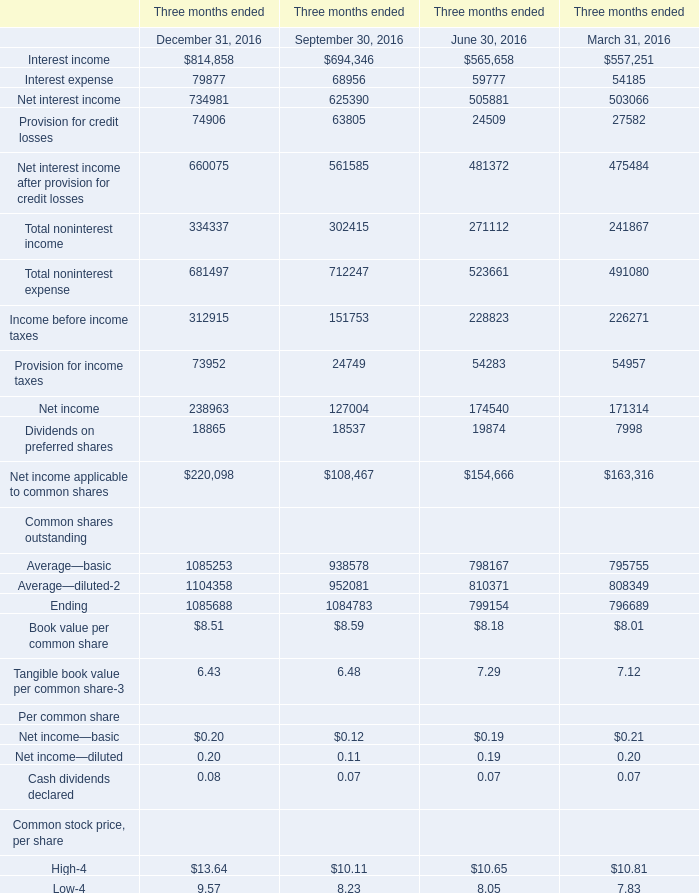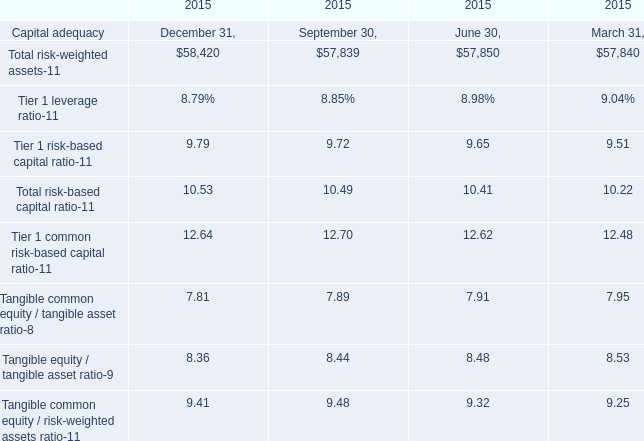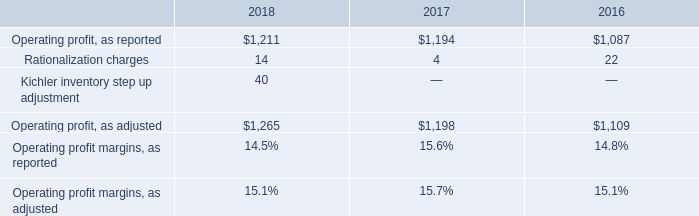what's the total amount of Operating profit, as reported of 2016, Net income of Three months ended December 31, 2016, and Total noninterest income of Three months ended March 31, 2016 ? 
Computations: ((1087.0 + 238963.0) + 241867.0)
Answer: 481917.0. 